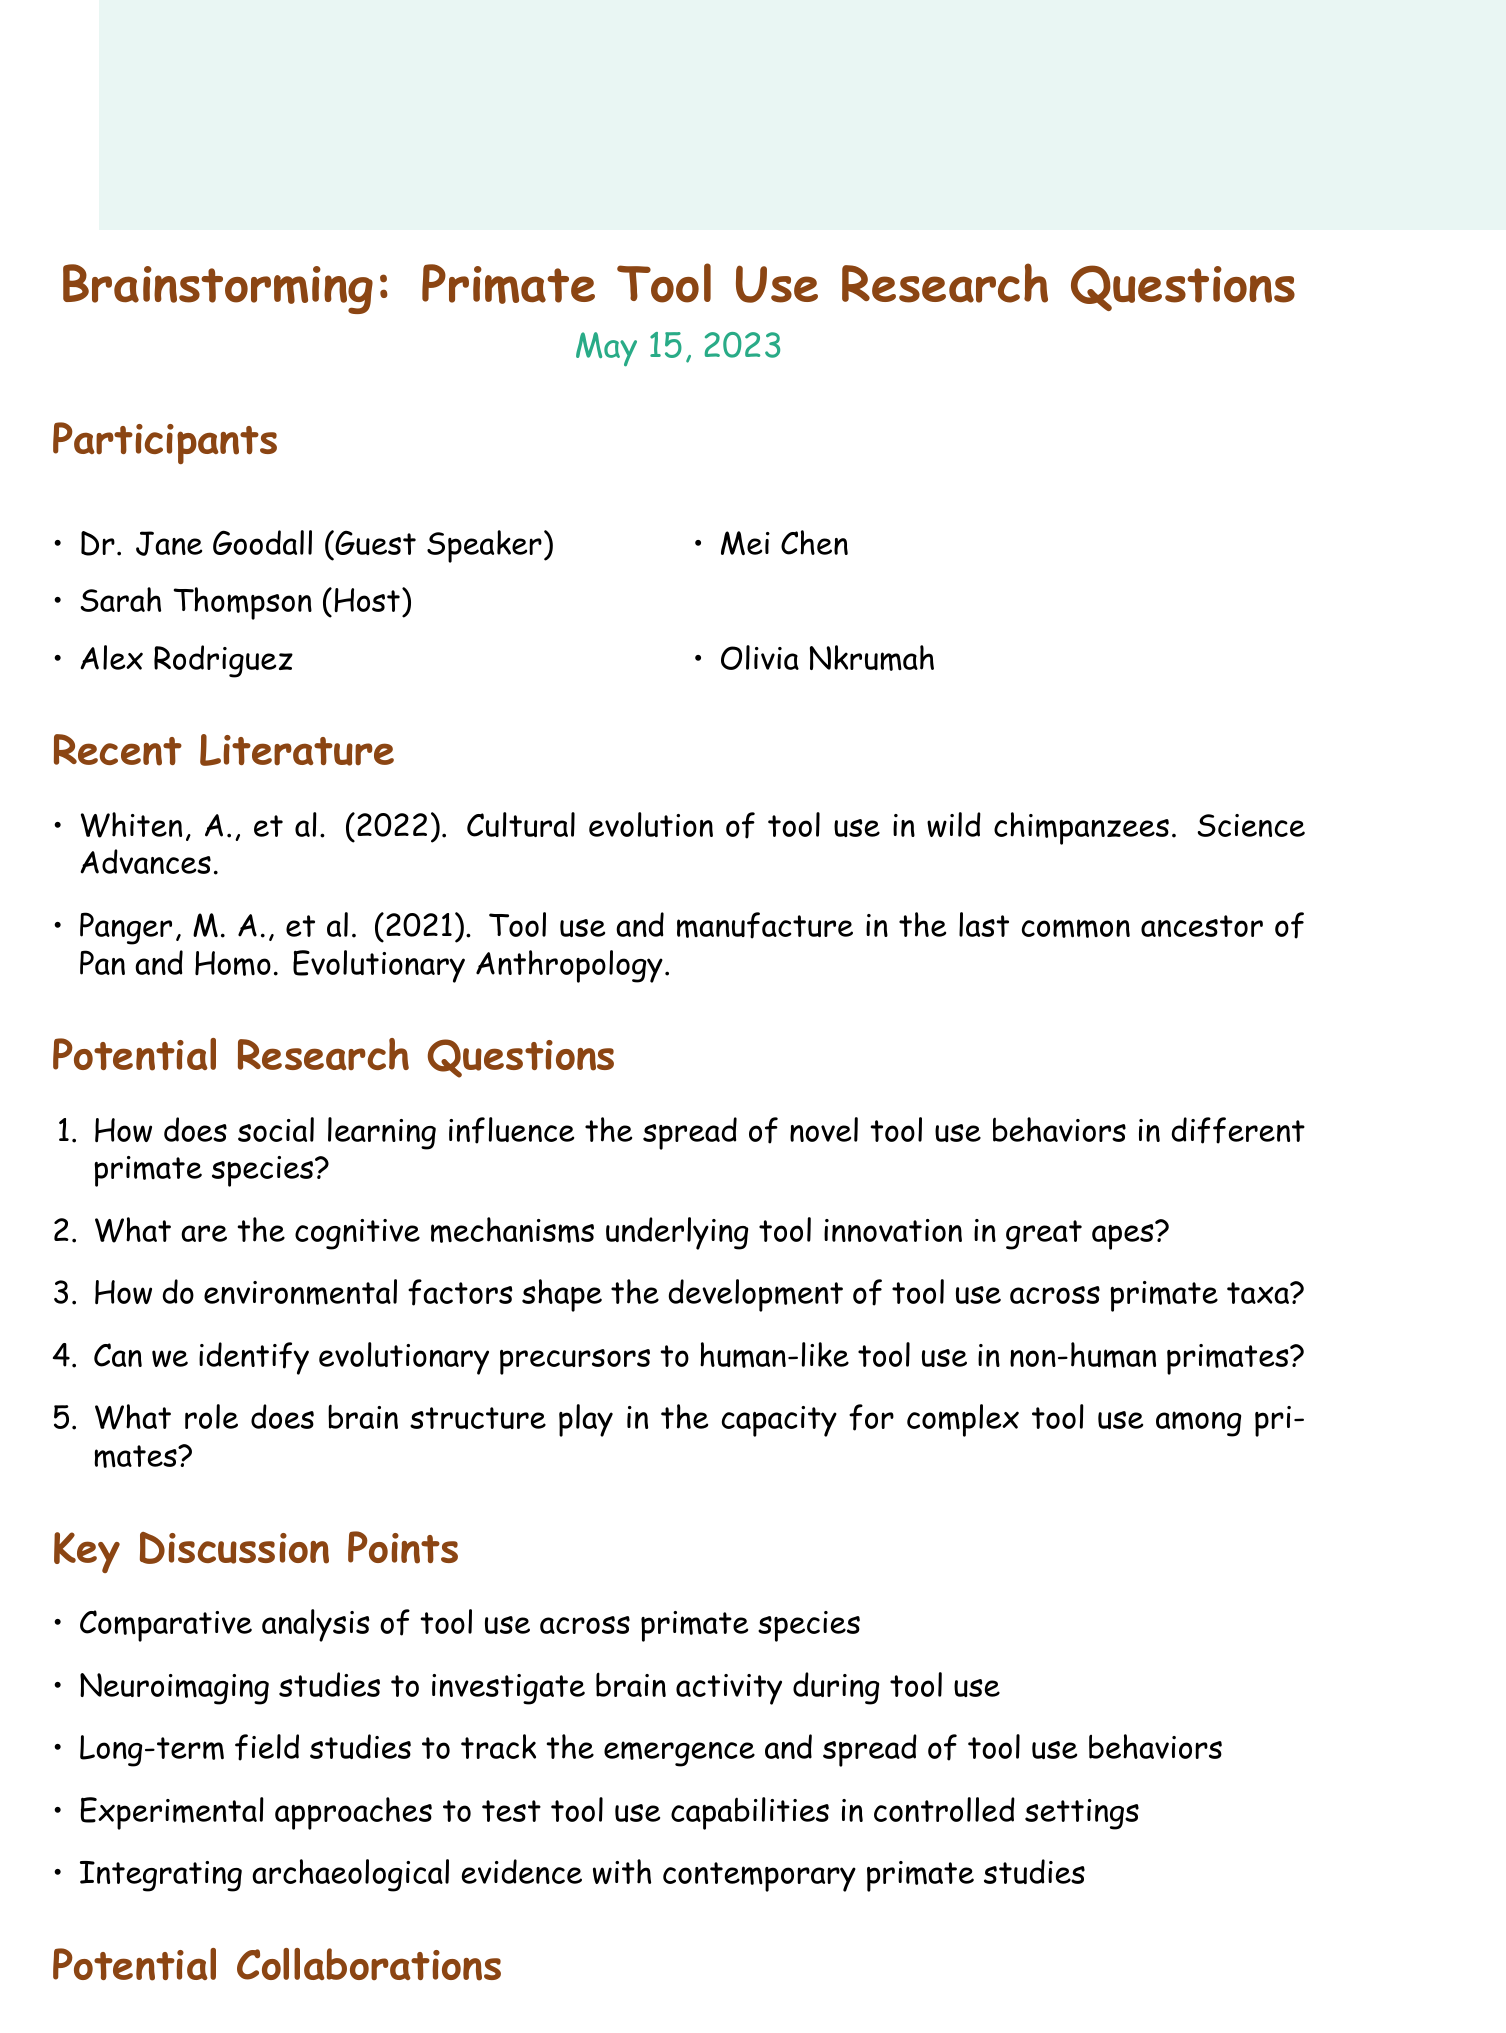What is the date of the brainstorming session? The date of the brainstorming session is explicitly mentioned in the document.
Answer: May 15, 2023 Who is the guest speaker at the session? The document lists Dr. Jane Goodall as the guest speaker among the participants.
Answer: Dr. Jane Goodall What is one of the recent literature titles mentioned? The document includes a list of recent literature, one of which is cited.
Answer: Cultural evolution of tool use in wild chimpanzees What type of funding opportunities are listed? The document explicitly states available funding opportunities related to primate research.
Answer: National Science Foundation (NSF) Biological Anthropology Program How many potential research questions are proposed? The document counts the potential research questions listed under that section.
Answer: Five What is a key discussion point related to experimental methods? The document mentions specific experimental approaches as one of the key discussion points.
Answer: Experimental approaches to test tool use capabilities in controlled settings What institution is mentioned for potential collaboration? The document lists potential collaborations, including a specific institution.
Answer: Max Planck Institute for Evolutionary Anthropology What is one of the cognitive mechanisms being studied? The potential research questions include a focus on cognitive mechanisms concerning tool innovation.
Answer: Cognitive mechanisms underlying tool innovation in great apes Can we identify evolutionary precursors to human-like tool use? This question is proposed as one of the potential research questions in the document.
Answer: Yes 